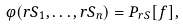Convert formula to latex. <formula><loc_0><loc_0><loc_500><loc_500>\varphi ( r S _ { 1 } , \dots , r S _ { n } ) = { P } _ { r S } [ f ] ,</formula> 